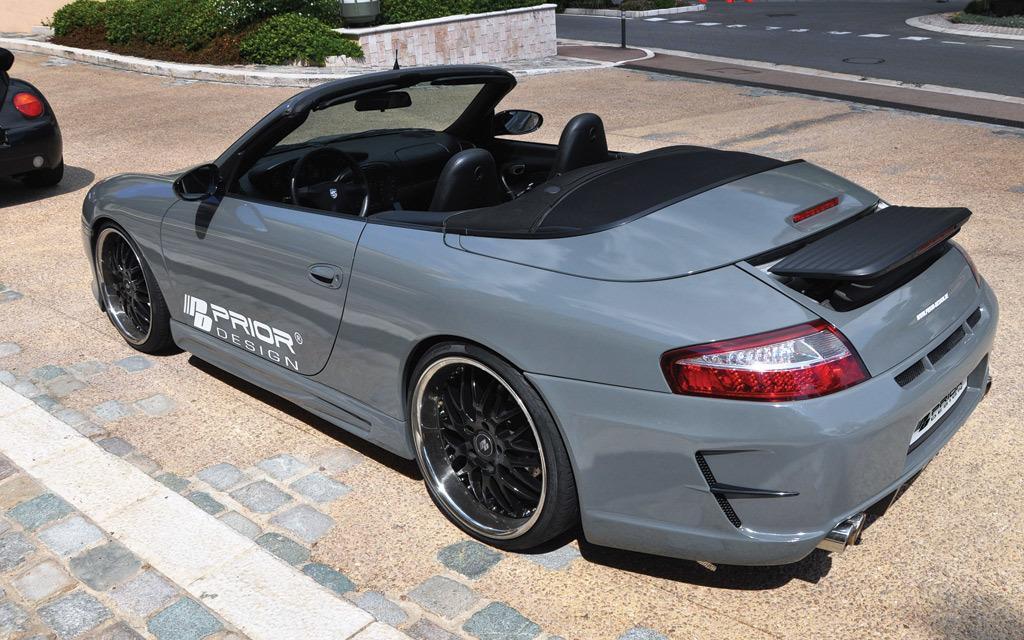Describe this image in one or two sentences. This is a gray color roof top car. And there is something written on the front door. In the background there is a road, and a wall and also there are some bushes. 